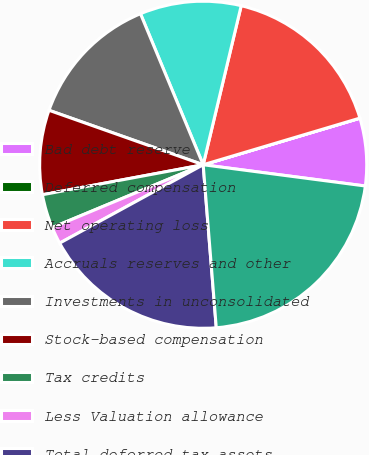Convert chart. <chart><loc_0><loc_0><loc_500><loc_500><pie_chart><fcel>Bad debt reserve<fcel>Deferred compensation<fcel>Net operating loss<fcel>Accruals reserves and other<fcel>Investments in unconsolidated<fcel>Stock-based compensation<fcel>Tax credits<fcel>Less Valuation allowance<fcel>Total deferred tax assets<fcel>Property and equipment<nl><fcel>6.67%<fcel>0.01%<fcel>16.66%<fcel>10.0%<fcel>13.33%<fcel>8.34%<fcel>3.34%<fcel>1.68%<fcel>18.32%<fcel>21.65%<nl></chart> 